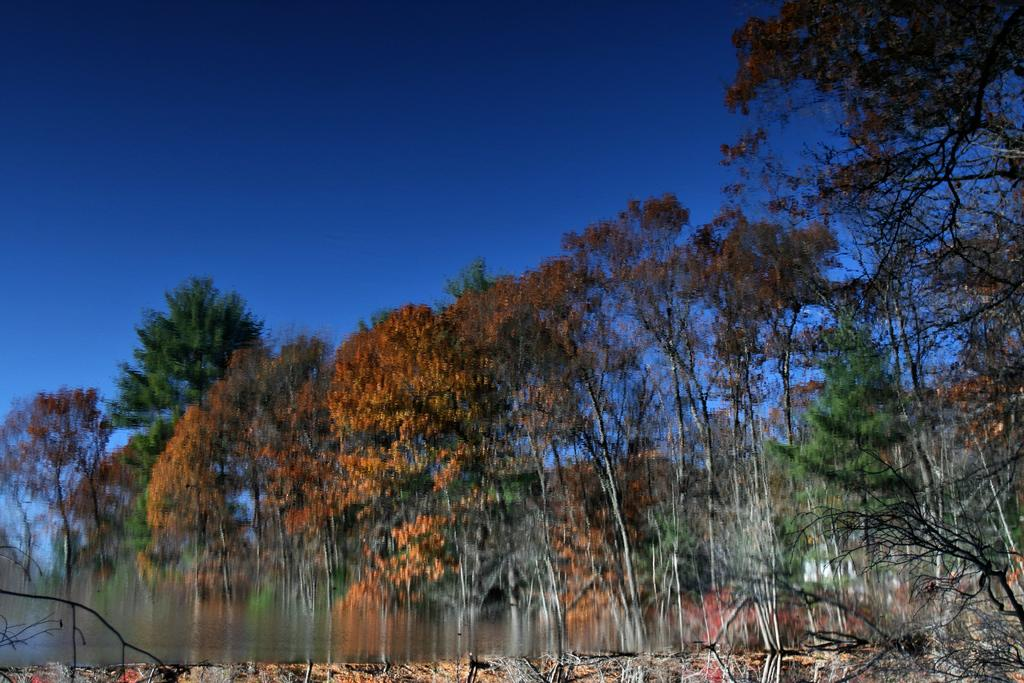What has been done to the image? The image has been edited. What type of natural elements can be seen in the image? There are trees in the image. What is visible at the top of the image? The sky is visible at the top of the image. What color is the sky in the image? The color of the sky is blue. What part of the image is blurred? The bottom part of the image is blurred. Is there a home visible near the lake in the image? There is no home or lake present in the image; it only features trees and a blue sky. 